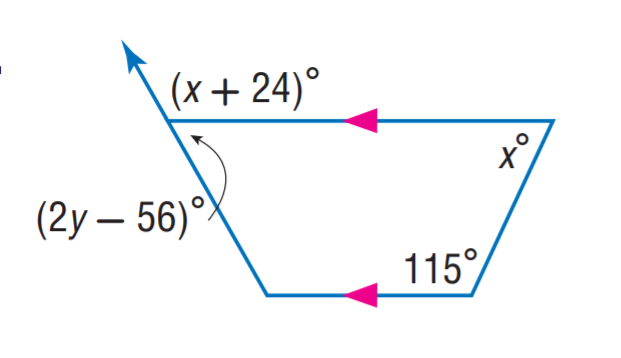Answer the mathemtical geometry problem and directly provide the correct option letter.
Question: Find y.
Choices: A: 56 B: 65 C: 73.5 D: 115 C 